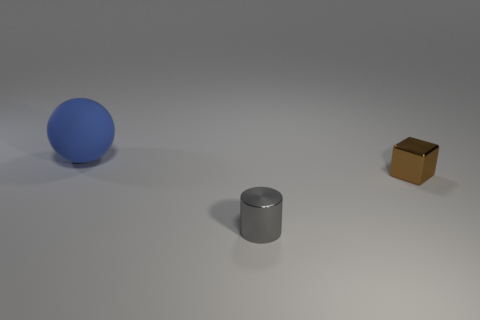Add 3 large red metal cylinders. How many objects exist? 6 Subtract all spheres. How many objects are left? 2 Subtract all small green shiny objects. Subtract all gray metal things. How many objects are left? 2 Add 1 small brown blocks. How many small brown blocks are left? 2 Add 2 tiny metallic cubes. How many tiny metallic cubes exist? 3 Subtract 0 red cylinders. How many objects are left? 3 